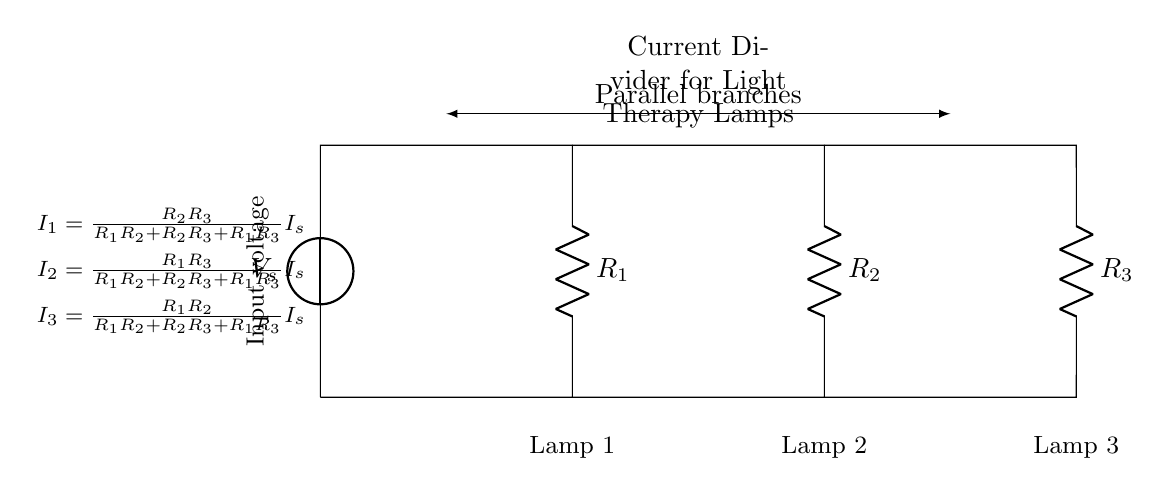What is the type of circuit represented? The circuit is a parallel circuit as indicated by the multiple branches that connect the voltage source to the various resistors and lamps.
Answer: Parallel circuit How many lamps are in the circuit? The circuit diagram shows three lamps connected in parallel, each corresponding to one of the resistors.
Answer: Three lamps Which resistor will have the highest current flowing through it? In a current divider circuit, the resistor with the lowest resistance (R1, R2, or R3) will have the highest current as current divides inversely with resistance. You need to identify which resistor has the smallest value, but it is not specified in this case.
Answer: Lowest resistance What is the function of the resistors in this circuit? The resistors in this circuit control how the total current from the source divides among the parallel branches, thereby controlling the intensity of the light from each lamp based on the resistance values.
Answer: Control light intensity If the input current is 10 Amperes, what is the current through Lamp 1 if R1 is the smallest resistor? To find the current through Lamp 1, we apply the current divider formula: I1 = (R2*R3 / (R1*R2 + R2*R3 + R1*R3)) * Is. Assuming R1 < R2 and R3, this will give a significant proportion of the total current to Lamp 1. However, without knowing resistor values, we cannot specify the exact current.
Answer: Proportionate value based on resistors What determines how the total current is divided among the lamps? The current distribution among the lamps is determined by the resistance values of R1, R2, and R3. Lower resistance in a particular branch allows more current to flow through that branch compared to others with higher resistance.
Answer: Resistance values 